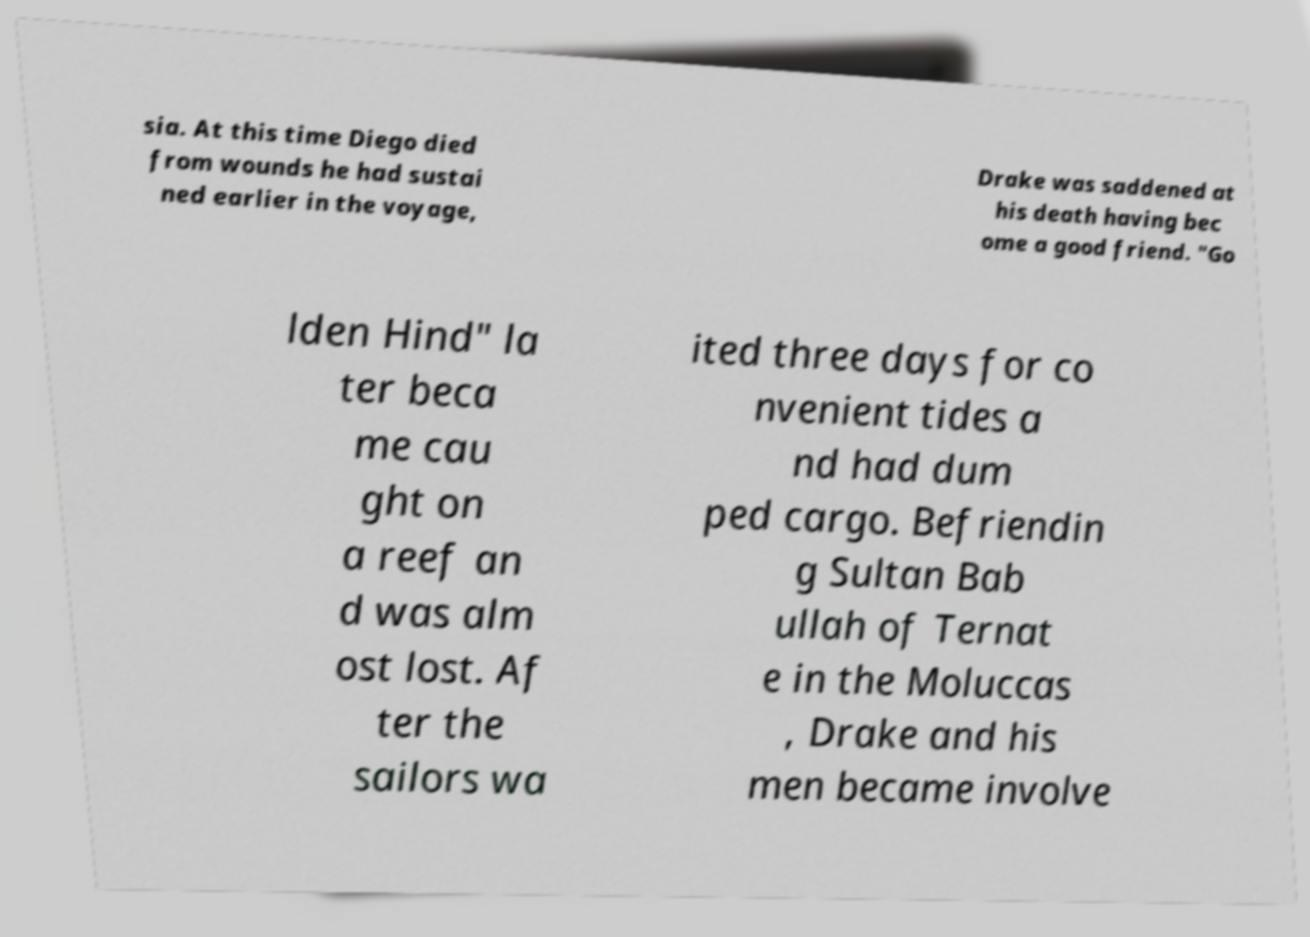What messages or text are displayed in this image? I need them in a readable, typed format. sia. At this time Diego died from wounds he had sustai ned earlier in the voyage, Drake was saddened at his death having bec ome a good friend. "Go lden Hind" la ter beca me cau ght on a reef an d was alm ost lost. Af ter the sailors wa ited three days for co nvenient tides a nd had dum ped cargo. Befriendin g Sultan Bab ullah of Ternat e in the Moluccas , Drake and his men became involve 